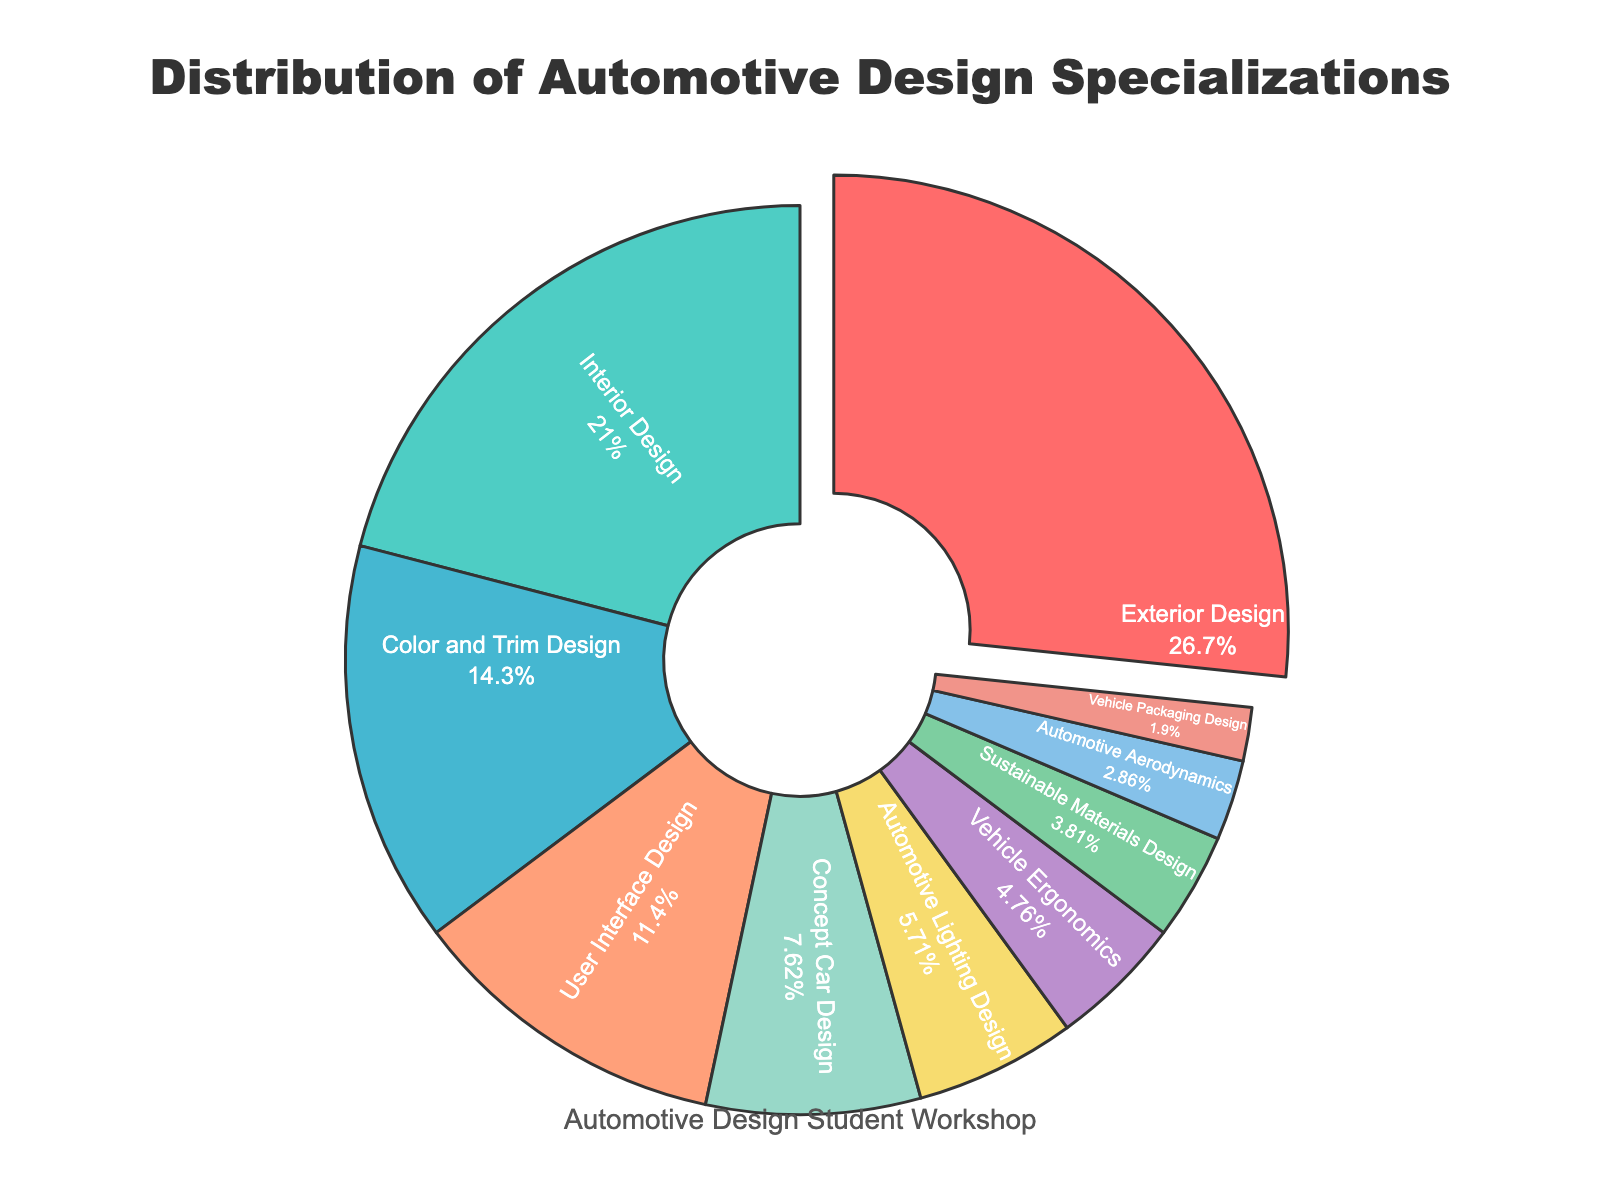What is the most common automotive design specialization among students? The pie chart shows the distribution of specializations, and we can see that the largest slice is for Exterior Design, indicating it is the most common.
Answer: Exterior Design Which two specializations have a combined percentage of more than 40%? We look for the sum of the percentages of two specializations that exceed 40%. Exterior Design (28%) and Interior Design (22%) together make 50%, which is more than 40%.
Answer: Exterior Design and Interior Design What is the percentage difference between User Interface Design and Concept Car Design? Subtract the percentage of Concept Car Design (8%) from that of User Interface Design (12%). The difference is 4%.
Answer: 4% Which specialization has the least proportion of students? The smallest slice in the pie chart represents Vehicle Packaging Design with a percentage of 2%.
Answer: Vehicle Packaging Design How many specializations have a percentage less than or equal to 10%? Count the segments with percentages less than or equal to 10%. They are: Concept Car Design (8%), Automotive Lighting Design (6%), Vehicle Ergonomics (5%), Sustainable Materials Design (4%), Automotive Aerodynamics (3%), and Vehicle Packaging Design (2%).
Answer: 6 Which specialization is represented by the second smallest slice in the chart? The smallest slice is for Vehicle Packaging Design (2%), and the next smallest is Automotive Aerodynamics (3%).
Answer: Automotive Aerodynamics If you combine the percentages of Color and Trim Design and User Interface Design, does it exceed the percentage of Exterior Design? Add the percentages of Color and Trim Design (15%) and User Interface Design (12%), which equals 27%. Exterior Design has 28%, so it does not exceed it.
Answer: No What colors are used for the slices representing Exterior Design and Interior Design? The pie chart color list shows Exterior Design is represented by red and Interior Design by green.
Answer: Red and Green Which specialization has a percentage that is closest to the percentage of Sustainable Materials Design? Sustainable Materials Design has 4%. Vehicle Ergonomics has 5%, which is the closest value.
Answer: Vehicle Ergonomics How many more students are specializing in Color and Trim Design compared to Automotive Lighting Design? Subtract the percentage of Automotive Lighting Design (6%) from Color and Trim Design (15%), resulting in a difference of 9%.
Answer: 9% 